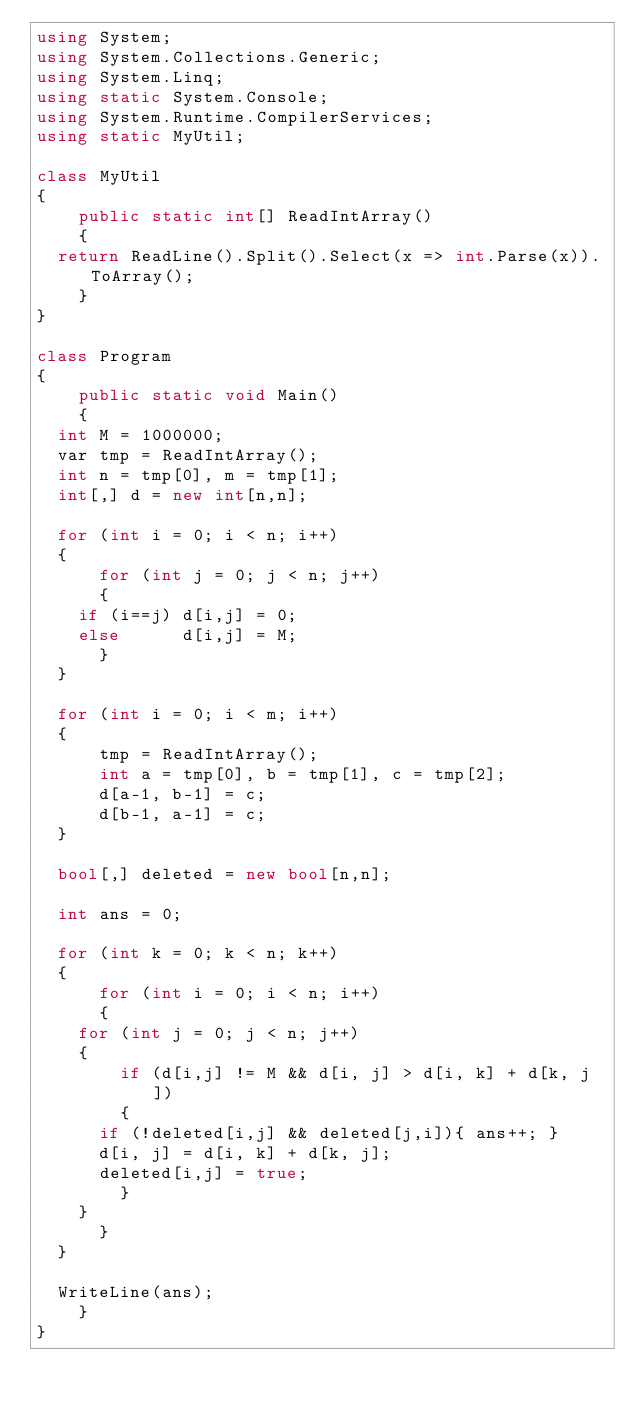<code> <loc_0><loc_0><loc_500><loc_500><_C#_>using System;
using System.Collections.Generic;
using System.Linq;
using static System.Console;
using System.Runtime.CompilerServices;
using static MyUtil;

class MyUtil
{
    public static int[] ReadIntArray()
    {
	return ReadLine().Split().Select(x => int.Parse(x)).ToArray();
    }
}

class Program
{
    public static void Main()
    {
	int M = 1000000;
	var tmp = ReadIntArray();
	int n = tmp[0], m = tmp[1];
	int[,] d = new int[n,n];

	for (int i = 0; i < n; i++)
	{
	    for (int j = 0; j < n; j++)
	    {
		if (i==j) d[i,j] = 0;
		else      d[i,j] = M;
	    }
	}

	for (int i = 0; i < m; i++)
	{
	    tmp = ReadIntArray();
	    int a = tmp[0], b = tmp[1], c = tmp[2];
	    d[a-1, b-1] = c;
	    d[b-1, a-1] = c;
	}

	bool[,] deleted = new bool[n,n];

	int ans = 0;

	for (int k = 0; k < n; k++)
	{
	    for (int i = 0; i < n; i++)
	    {
		for (int j = 0; j < n; j++)
		{
		    if (d[i,j] != M && d[i, j] > d[i, k] + d[k, j])
		    {
			if (!deleted[i,j] && deleted[j,i]){ ans++; }
			d[i, j] = d[i, k] + d[k, j];
			deleted[i,j] = true;
		    }
		}
	    }
	}

	WriteLine(ans);
    }
}
</code> 